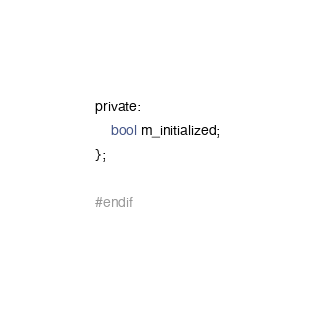<code> <loc_0><loc_0><loc_500><loc_500><_C_>
private:
    bool m_initialized;
};

#endif
</code> 